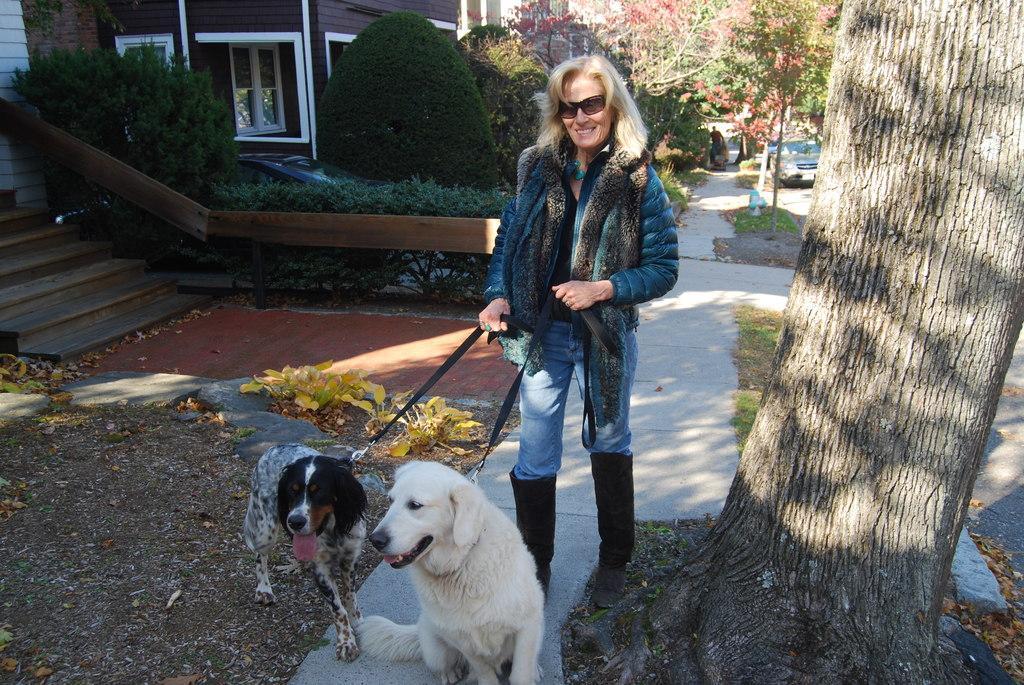In one or two sentences, can you explain what this image depicts? In this image in the front there are animals and there is a person standing and smiling and holding ropes which are tied to the animals. In the background there are trees, houses, plants, steps, cars and there is a person and there are dry leaves on the ground. 